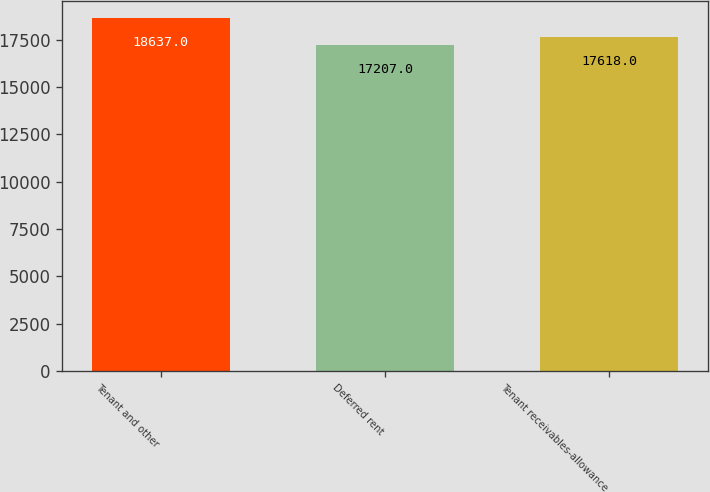Convert chart. <chart><loc_0><loc_0><loc_500><loc_500><bar_chart><fcel>Tenant and other<fcel>Deferred rent<fcel>Tenant receivables-allowance<nl><fcel>18637<fcel>17207<fcel>17618<nl></chart> 